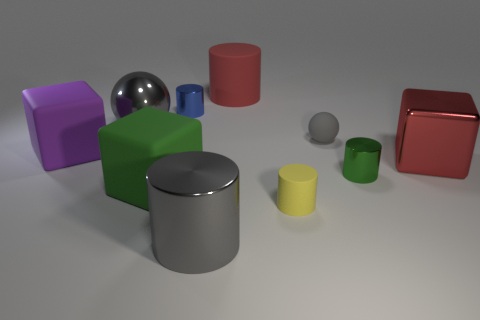Subtract all yellow cylinders. How many cylinders are left? 4 Subtract all large gray shiny cylinders. How many cylinders are left? 4 Subtract all brown cylinders. Subtract all blue blocks. How many cylinders are left? 5 Subtract all blocks. How many objects are left? 7 Subtract all tiny red metal cubes. Subtract all red matte objects. How many objects are left? 9 Add 7 yellow rubber cylinders. How many yellow rubber cylinders are left? 8 Add 4 tiny blue metallic objects. How many tiny blue metallic objects exist? 5 Subtract 2 gray spheres. How many objects are left? 8 